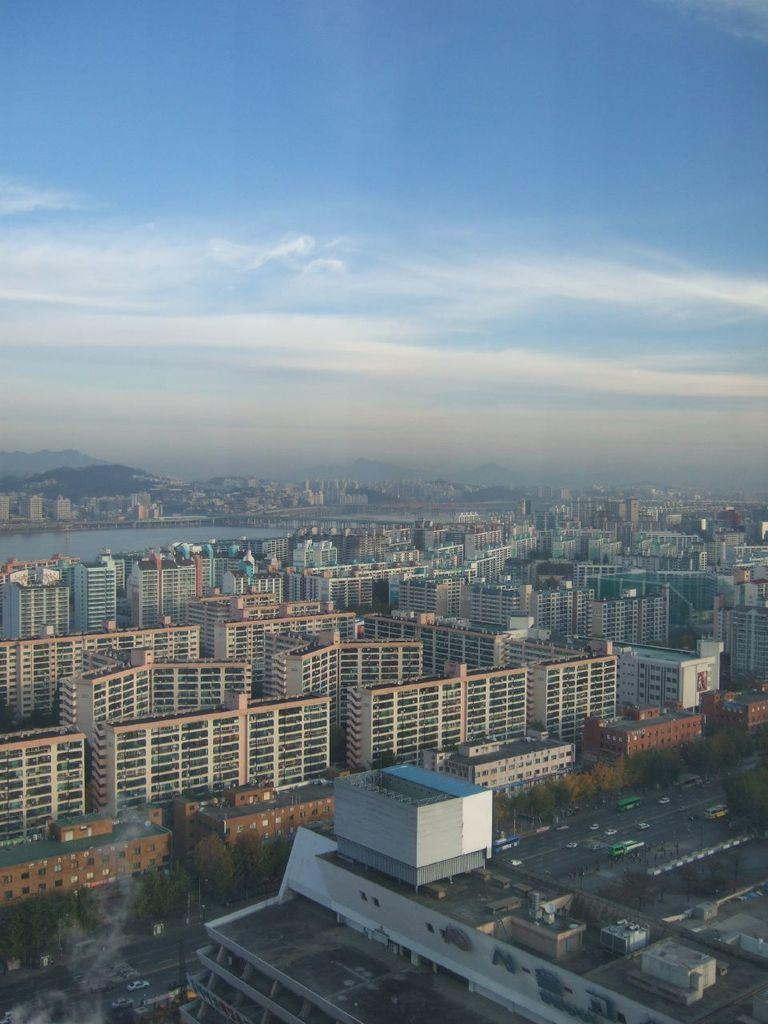What type of structures can be seen in the image? There are buildings in the image. What natural elements are present in the image? There are trees and a lake in the image. What type of transportation can be seen in the image? There are vehicles on the road in the image. What geographical features can be seen in the background of the image? There are hills visible in the background of the image. What is visible in the sky in the image? The sky is visible in the background of the image. Where is the throne located in the image? There is no throne present in the image. What type of picture is being taken of the image? The image itself is not a picture; it is the subject being described. 